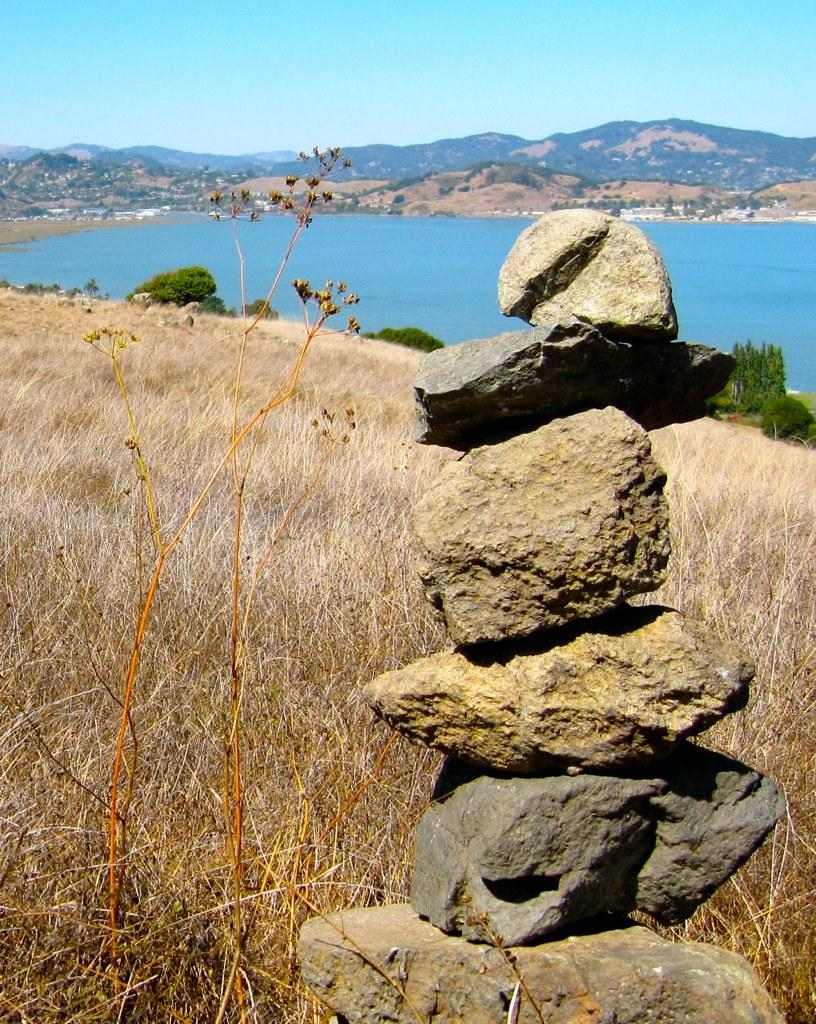What type of terrain is visible in the foreground of the image? There are stones in the foreground of the image. What type of vegetation is present at the bottom of the image? There is grass at the bottom of the image. What type of landscape can be seen in the background of the image? There are mountains in the background of the image. What natural feature is visible in the image? There is water visible in the image. What type of prison can be seen in the image? There is no prison present in the image. How does the loaf of bread control the water in the image? There is no loaf of bread present in the image, and therefore it cannot control the water. 